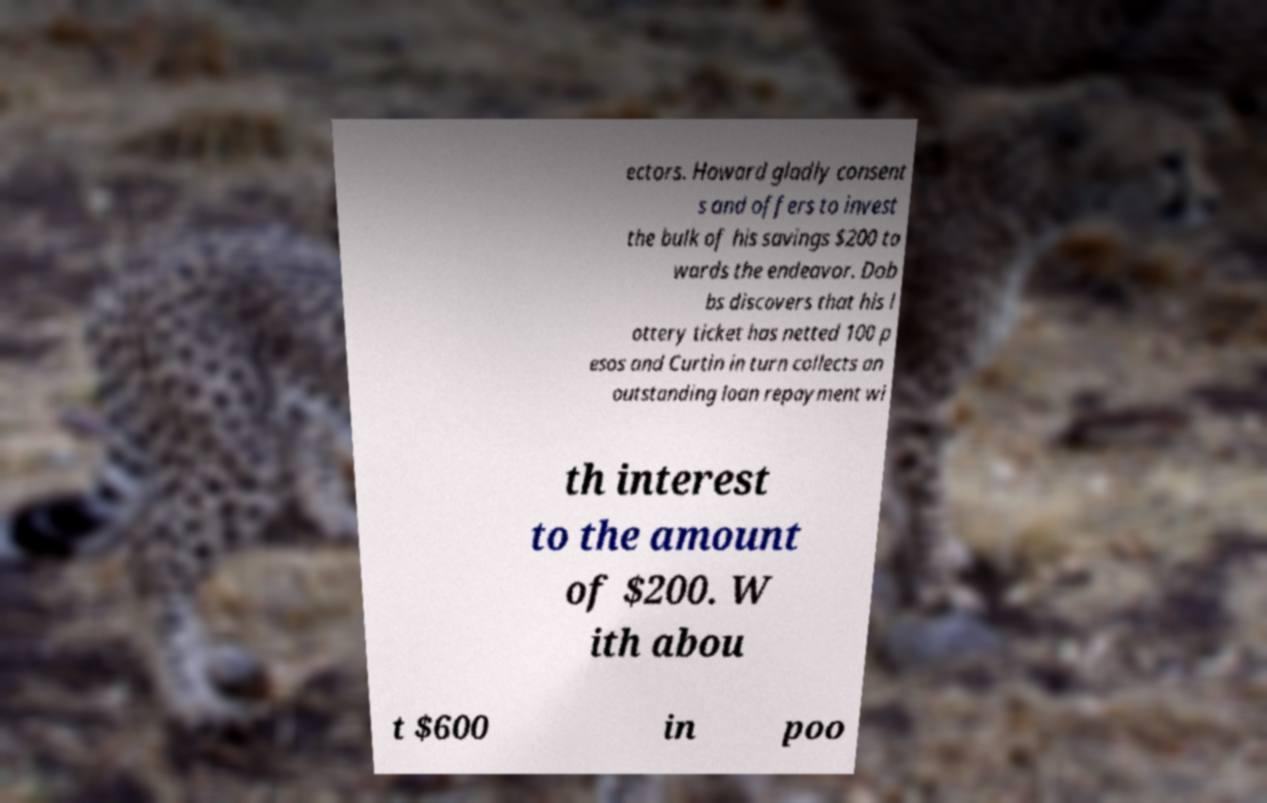Can you read and provide the text displayed in the image?This photo seems to have some interesting text. Can you extract and type it out for me? ectors. Howard gladly consent s and offers to invest the bulk of his savings $200 to wards the endeavor. Dob bs discovers that his l ottery ticket has netted 100 p esos and Curtin in turn collects an outstanding loan repayment wi th interest to the amount of $200. W ith abou t $600 in poo 